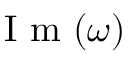<formula> <loc_0><loc_0><loc_500><loc_500>I m ( \omega )</formula> 